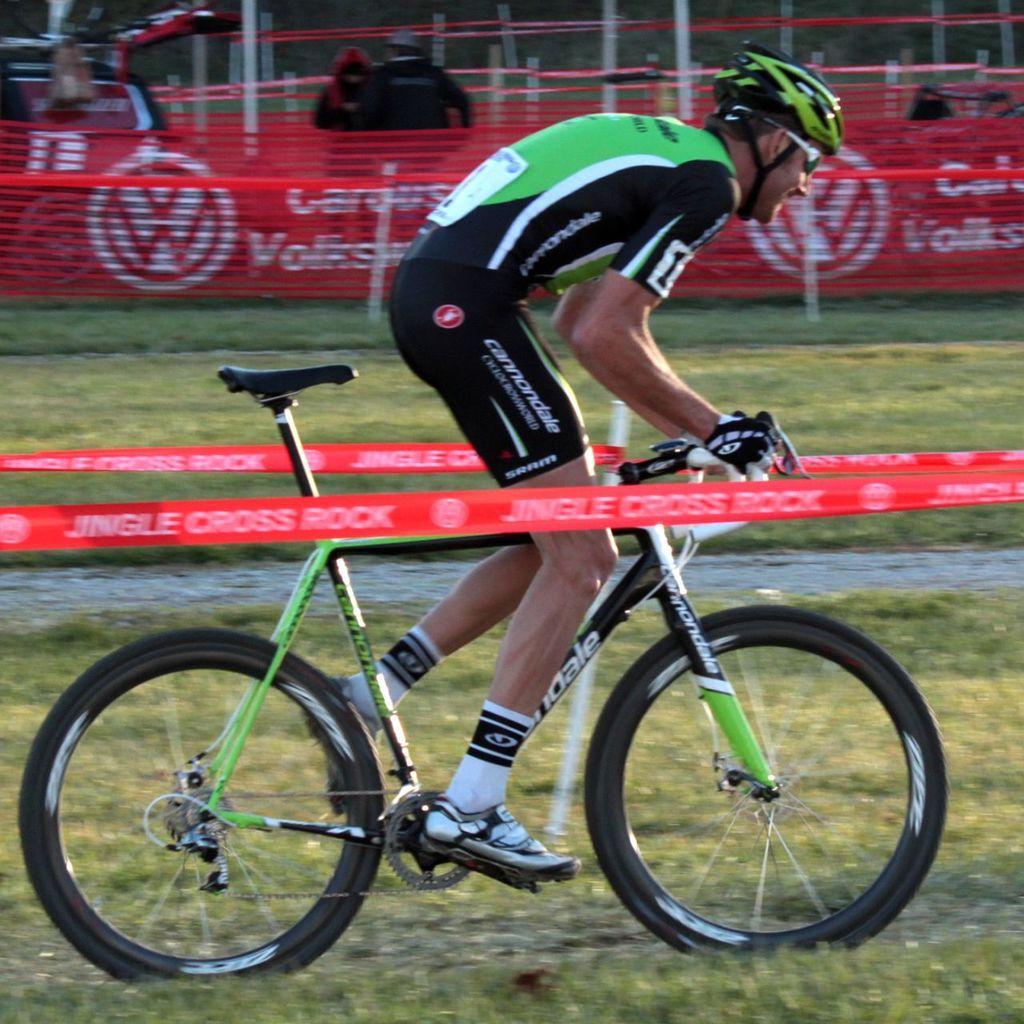In one or two sentences, can you explain what this image depicts? In this image I can see a person wearing black, green and white colored dress and green color helmet is riding a bicycle which is black and green in color. I can see two red colored bands and in the background I can see few persons, aboard, some grass and few white colored poles. 